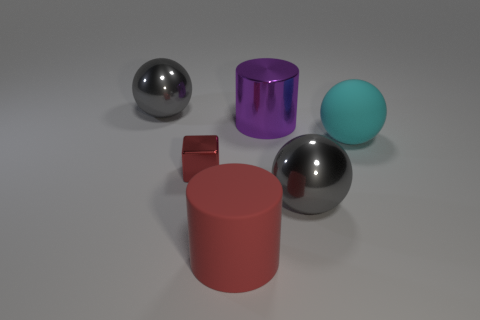What color is the shiny ball that is to the right of the big ball that is to the left of the large rubber thing that is in front of the tiny shiny thing?
Your answer should be very brief. Gray. Does the gray object that is behind the large purple metallic cylinder have the same material as the cylinder behind the matte ball?
Offer a very short reply. Yes. What number of things are large gray balls that are to the right of the large matte cylinder or big objects?
Make the answer very short. 5. How many things are cyan shiny objects or large objects behind the large cyan rubber thing?
Ensure brevity in your answer.  2. What number of purple cylinders are the same size as the red cylinder?
Your answer should be very brief. 1. Is the number of big gray metallic objects on the right side of the shiny cylinder less than the number of small things that are in front of the tiny metallic block?
Provide a short and direct response. No. What number of metal things are balls or small cubes?
Your response must be concise. 3. There is a tiny metal object; what shape is it?
Offer a very short reply. Cube. What material is the red thing that is the same size as the cyan matte ball?
Provide a short and direct response. Rubber. What number of large objects are cyan matte spheres or cyan blocks?
Offer a very short reply. 1. 